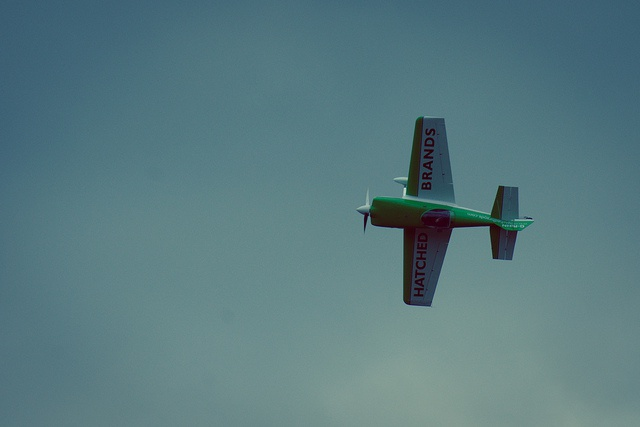Describe the objects in this image and their specific colors. I can see a airplane in blue, black, and teal tones in this image. 